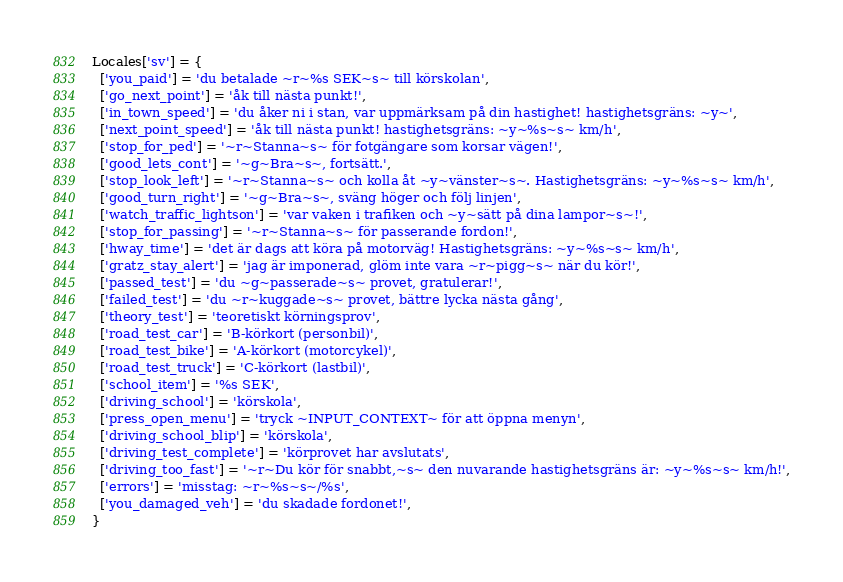Convert code to text. <code><loc_0><loc_0><loc_500><loc_500><_Lua_>Locales['sv'] = {
  ['you_paid'] = 'du betalade ~r~%s SEK~s~ till körskolan',
  ['go_next_point'] = 'åk till nästa punkt!',
  ['in_town_speed'] = 'du åker ni i stan, var uppmärksam på din hastighet! hastighetsgräns: ~y~',
  ['next_point_speed'] = 'åk till nästa punkt! hastighetsgräns: ~y~%s~s~ km/h',
  ['stop_for_ped'] = '~r~Stanna~s~ för fotgängare som korsar vägen!',
  ['good_lets_cont'] = '~g~Bra~s~, fortsätt.',
  ['stop_look_left'] = '~r~Stanna~s~ och kolla åt ~y~vänster~s~. Hastighetsgräns: ~y~%s~s~ km/h',
  ['good_turn_right'] = '~g~Bra~s~, sväng höger och följ linjen',
  ['watch_traffic_lightson'] = 'var vaken i trafiken och ~y~sätt på dina lampor~s~!',
  ['stop_for_passing'] = '~r~Stanna~s~ för passerande fordon!',
  ['hway_time'] = 'det är dags att köra på motorväg! Hastighetsgräns: ~y~%s~s~ km/h',
  ['gratz_stay_alert'] = 'jag är imponerad, glöm inte vara ~r~pigg~s~ när du kör!',
  ['passed_test'] = 'du ~g~passerade~s~ provet, gratulerar!',
  ['failed_test'] = 'du ~r~kuggade~s~ provet, bättre lycka nästa gång',
  ['theory_test'] = 'teoretiskt körningsprov',
  ['road_test_car'] = 'B-körkort (personbil)',
  ['road_test_bike'] = 'A-körkort (motorcykel)',
  ['road_test_truck'] = 'C-körkort (lastbil)',
  ['school_item'] = '%s SEK',
  ['driving_school'] = 'körskola',
  ['press_open_menu'] = 'tryck ~INPUT_CONTEXT~ för att öppna menyn',
  ['driving_school_blip'] = 'körskola',
  ['driving_test_complete'] = 'körprovet har avslutats',
  ['driving_too_fast'] = '~r~Du kör för snabbt,~s~ den nuvarande hastighetsgräns är: ~y~%s~s~ km/h!',
  ['errors'] = 'misstag: ~r~%s~s~/%s',
  ['you_damaged_veh'] = 'du skadade fordonet!',
}
</code> 